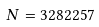Convert formula to latex. <formula><loc_0><loc_0><loc_500><loc_500>N = 3 2 8 2 2 5 7</formula> 